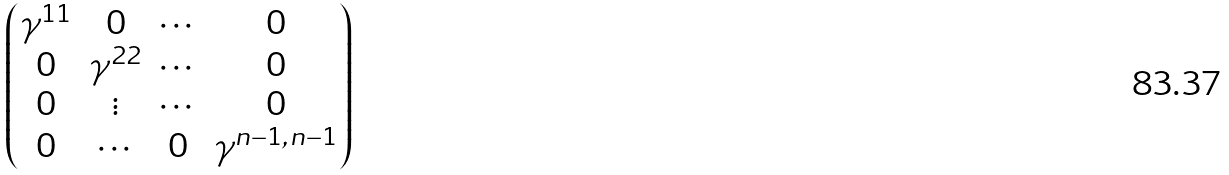<formula> <loc_0><loc_0><loc_500><loc_500>\begin{pmatrix} \gamma ^ { 1 1 } & 0 & \cdots & 0 \\ 0 & \gamma ^ { 2 2 } & \cdots & 0 \\ 0 & \vdots & \cdots & 0 \\ 0 & \cdots & 0 & \gamma ^ { n - 1 , n - 1 } \end{pmatrix}</formula> 